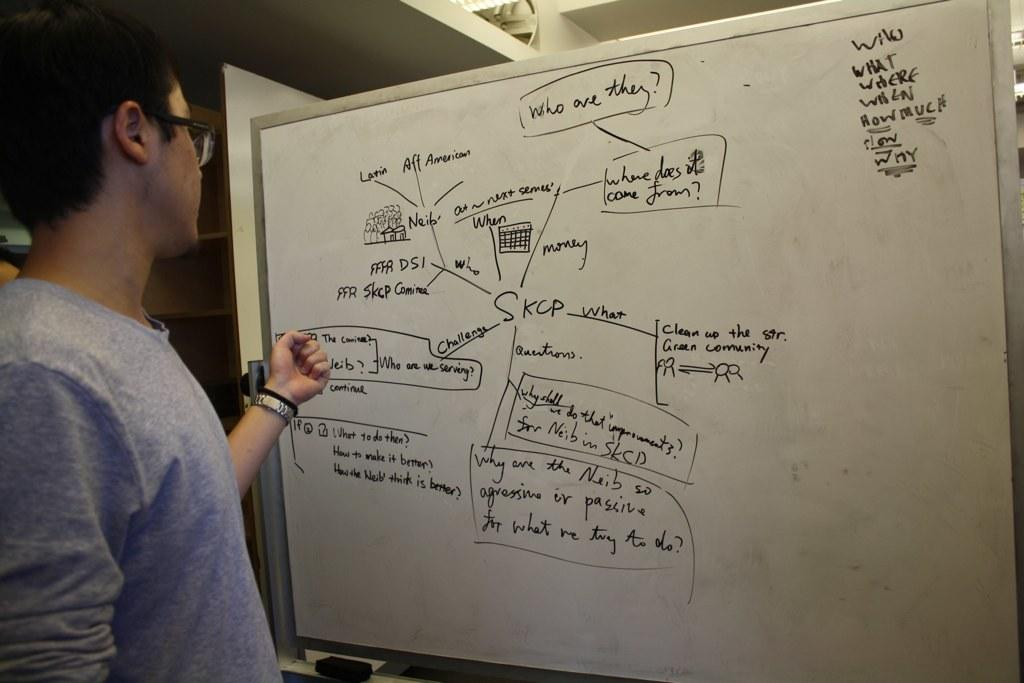<image>
Summarize the visual content of the image. A man stands in front of a whiteboard that has a flowchart that starts with "Who are they?" 